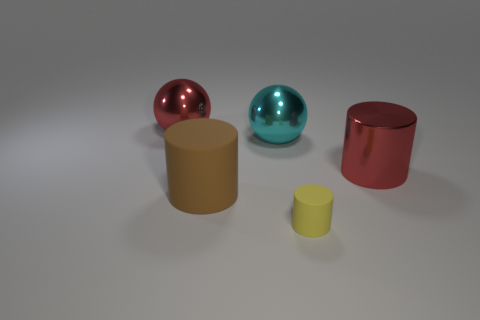Subtract all blue cylinders. Subtract all red blocks. How many cylinders are left? 3 Add 2 purple metallic cubes. How many objects exist? 7 Subtract all spheres. How many objects are left? 3 Subtract 0 blue cylinders. How many objects are left? 5 Subtract all matte cylinders. Subtract all cyan metallic spheres. How many objects are left? 2 Add 4 big cyan balls. How many big cyan balls are left? 5 Add 4 large red objects. How many large red objects exist? 6 